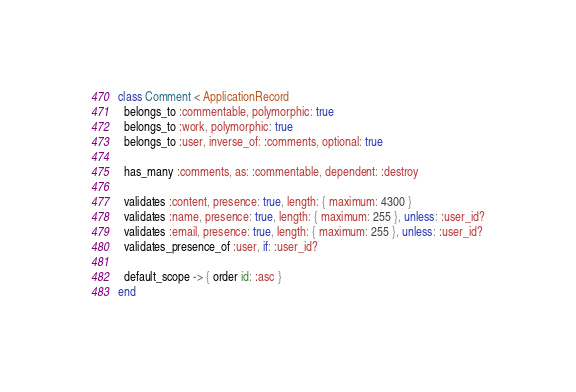<code> <loc_0><loc_0><loc_500><loc_500><_Ruby_>class Comment < ApplicationRecord
  belongs_to :commentable, polymorphic: true
  belongs_to :work, polymorphic: true
  belongs_to :user, inverse_of: :comments, optional: true

  has_many :comments, as: :commentable, dependent: :destroy

  validates :content, presence: true, length: { maximum: 4300 }
  validates :name, presence: true, length: { maximum: 255 }, unless: :user_id?
  validates :email, presence: true, length: { maximum: 255 }, unless: :user_id?
  validates_presence_of :user, if: :user_id?

  default_scope -> { order id: :asc }
end
</code> 